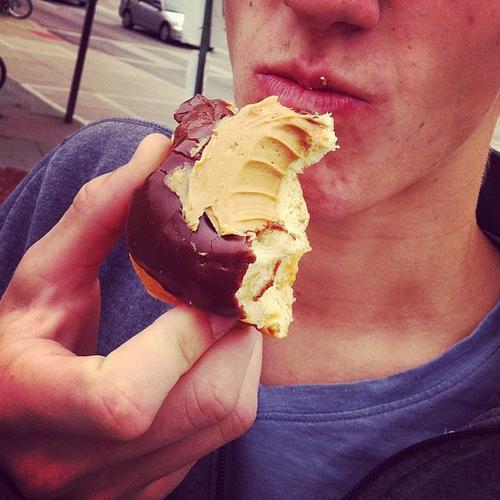How many people are eating?
Give a very brief answer. 1. How many fingers are shown?
Give a very brief answer. 4. How many sign post can be seen?
Give a very brief answer. 2. 